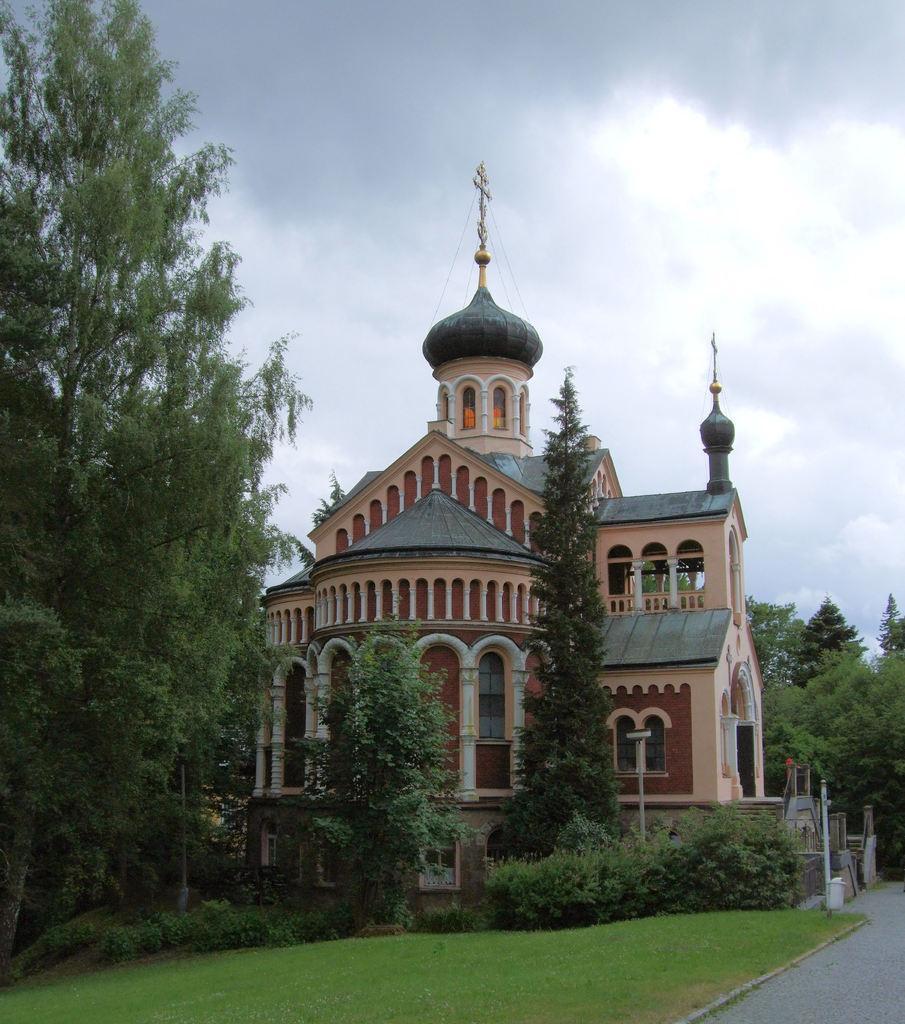Can you describe this image briefly? In the center of the image we can see building. On the left side of the image we can see trees. On the right side of the image we can see trees. At the bottom of the image we can see road, trees and grass. In the background we can see sky and clouds. 